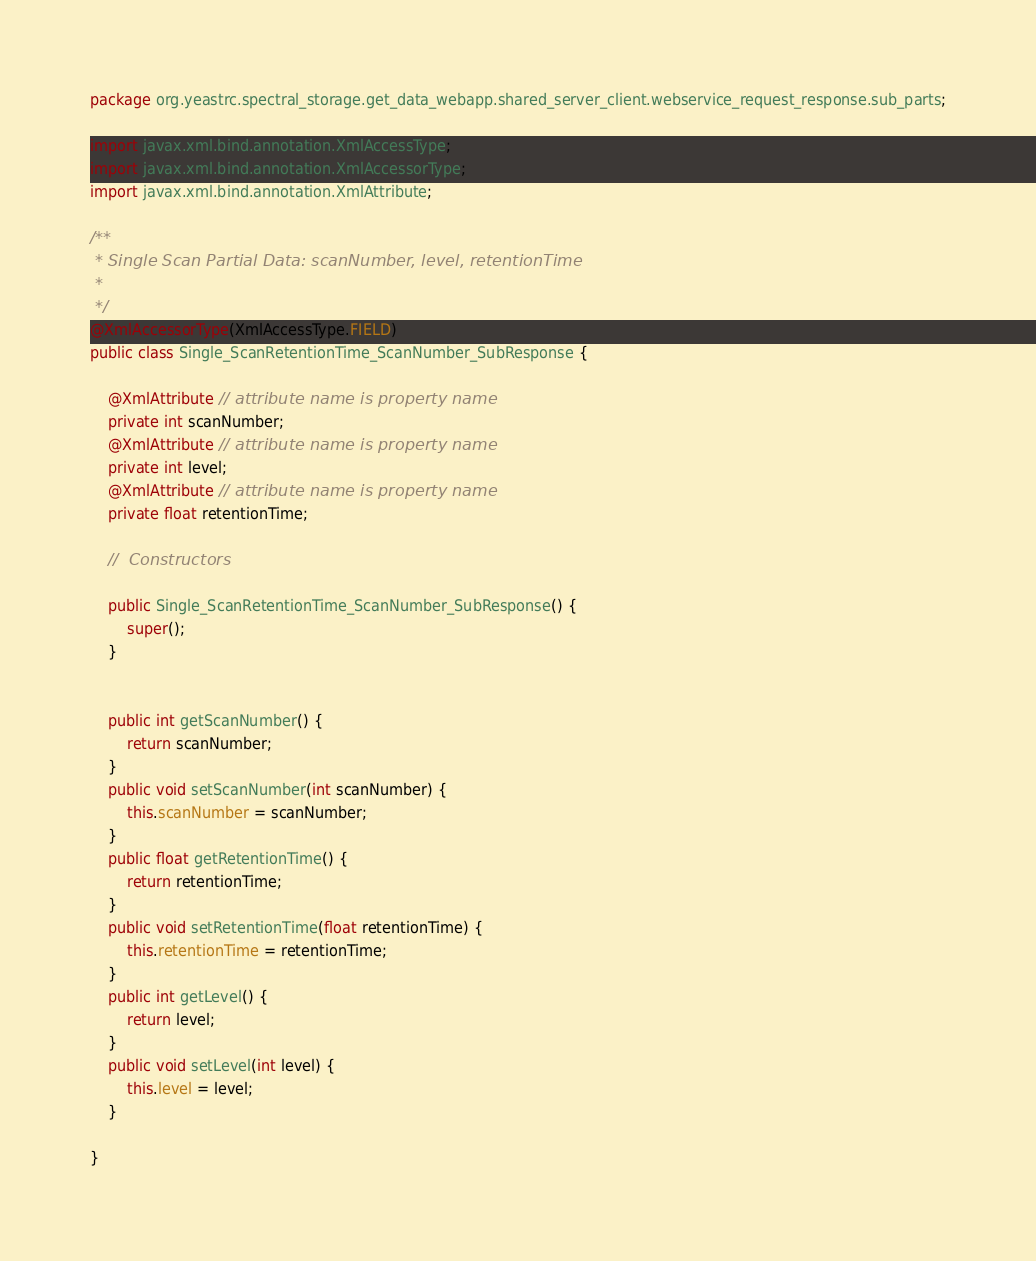<code> <loc_0><loc_0><loc_500><loc_500><_Java_>package org.yeastrc.spectral_storage.get_data_webapp.shared_server_client.webservice_request_response.sub_parts;

import javax.xml.bind.annotation.XmlAccessType;
import javax.xml.bind.annotation.XmlAccessorType;
import javax.xml.bind.annotation.XmlAttribute;

/**
 * Single Scan Partial Data: scanNumber, level, retentionTime
 *
 */
@XmlAccessorType(XmlAccessType.FIELD)
public class Single_ScanRetentionTime_ScanNumber_SubResponse {

	@XmlAttribute // attribute name is property name
	private int scanNumber;
	@XmlAttribute // attribute name is property name
	private int level;
	@XmlAttribute // attribute name is property name
	private float retentionTime;
	
	//  Constructors
	
	public Single_ScanRetentionTime_ScanNumber_SubResponse() {
		super();
	}
	
	
	public int getScanNumber() {
		return scanNumber;
	}
	public void setScanNumber(int scanNumber) {
		this.scanNumber = scanNumber;
	}
	public float getRetentionTime() {
		return retentionTime;
	}
	public void setRetentionTime(float retentionTime) {
		this.retentionTime = retentionTime;
	}
	public int getLevel() {
		return level;
	}
	public void setLevel(int level) {
		this.level = level;
	}

}
</code> 